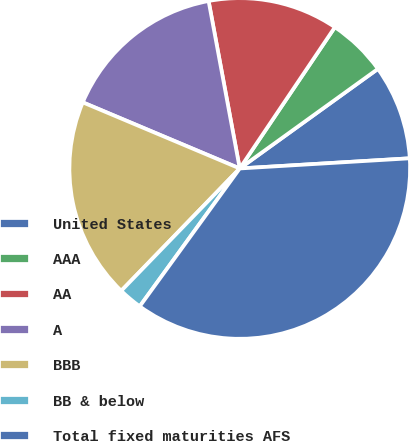<chart> <loc_0><loc_0><loc_500><loc_500><pie_chart><fcel>United States<fcel>AAA<fcel>AA<fcel>A<fcel>BBB<fcel>BB & below<fcel>Total fixed maturities AFS<nl><fcel>8.99%<fcel>5.63%<fcel>12.36%<fcel>15.73%<fcel>19.1%<fcel>2.26%<fcel>35.94%<nl></chart> 